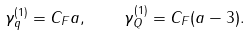Convert formula to latex. <formula><loc_0><loc_0><loc_500><loc_500>\gamma _ { q } ^ { ( 1 ) } = C _ { F } a , \quad \gamma _ { Q } ^ { ( 1 ) } = C _ { F } ( a - 3 ) .</formula> 